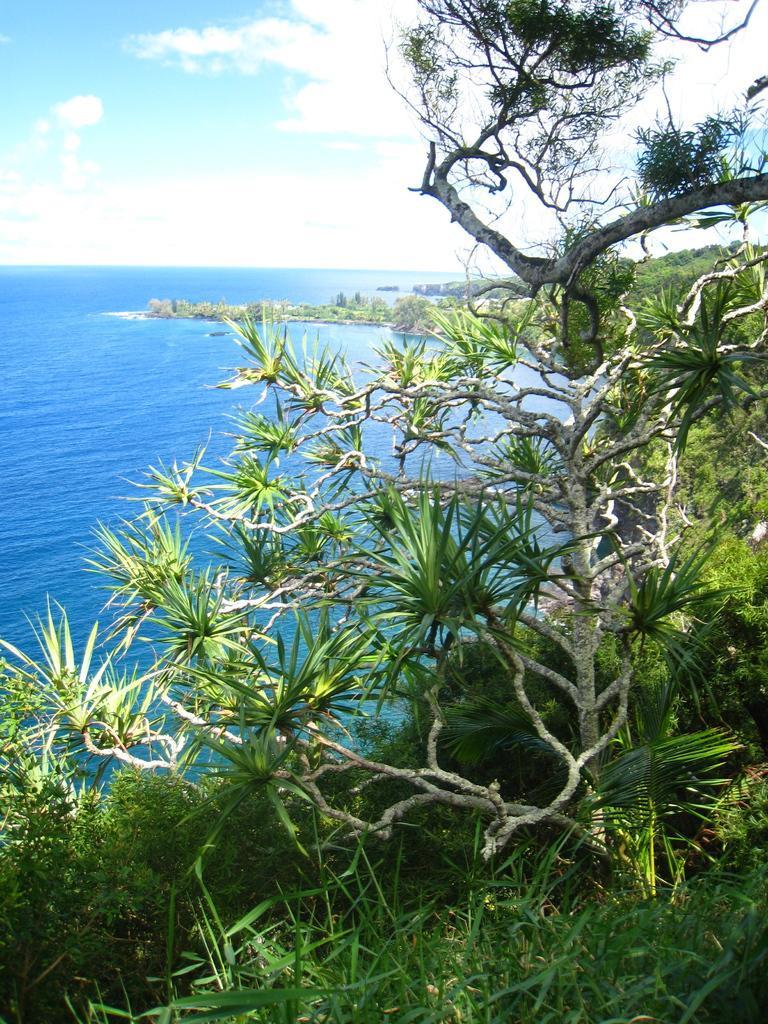What type of vegetation is in the foreground of the image? There is grass and trees in the foreground of the image. What can be seen in the background of the image? Water, the sky, and clouds are visible in the background of the image. How many elements are present in the background of the image? There are three elements present in the background: water, the sky, and clouds. What type of tub is visible in the image? There is no tub present in the image. How many cakes are being served in the image? There is no mention of cakes or any food items in the image. 